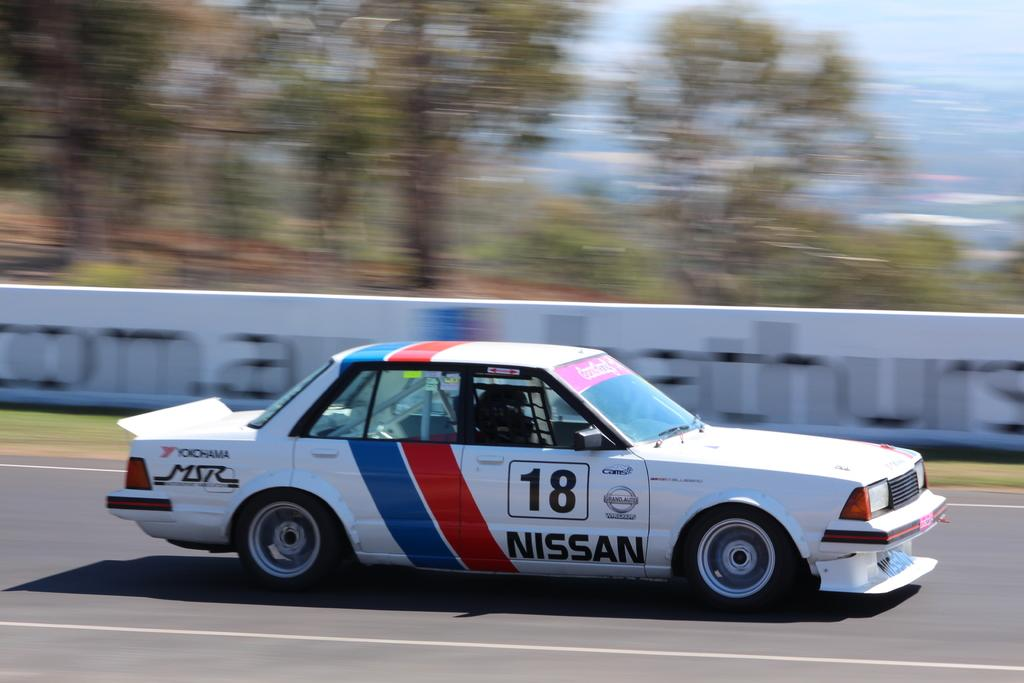What is the main subject in the center of the image? There is a car in the center of the image. What type of natural elements can be seen at the top side of the image? There are trees at the top side of the image. How many tickets are visible on the table in the image? There is no table or tickets present in the image; it only features a car and trees. 